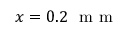Convert formula to latex. <formula><loc_0><loc_0><loc_500><loc_500>x = 0 . 2 m m</formula> 